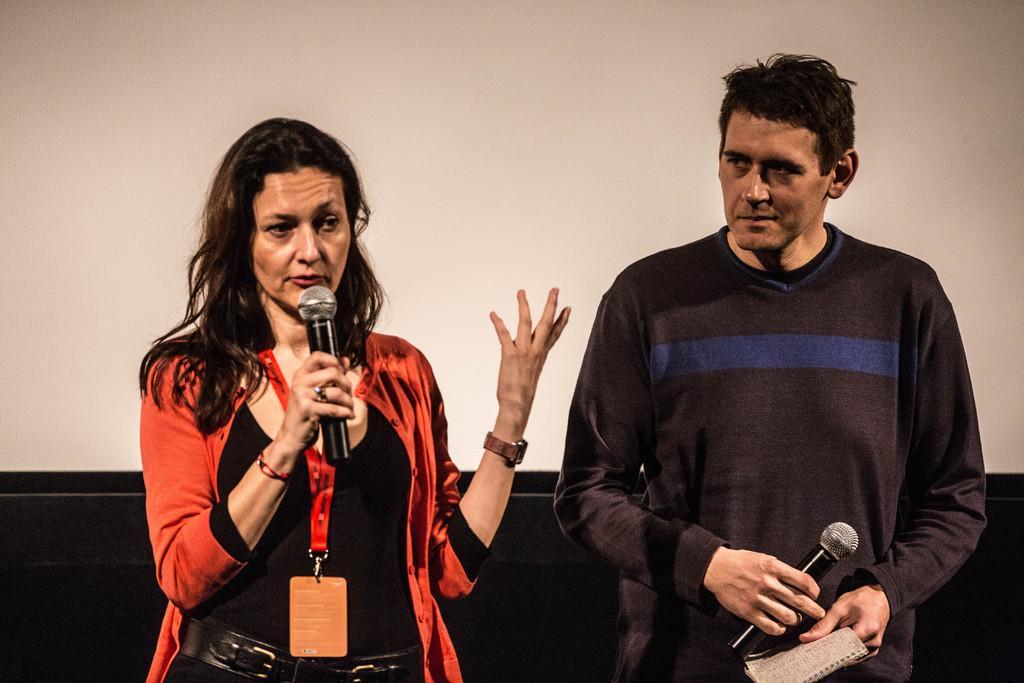Please provide a concise description of this image. In this image on the right, there is a man, he wears a t shirt, he is holding a mic and book. On the left there is a woman, she wears a t shirt, belt, trouser, she is holding a mic. In the background there is a wall. 